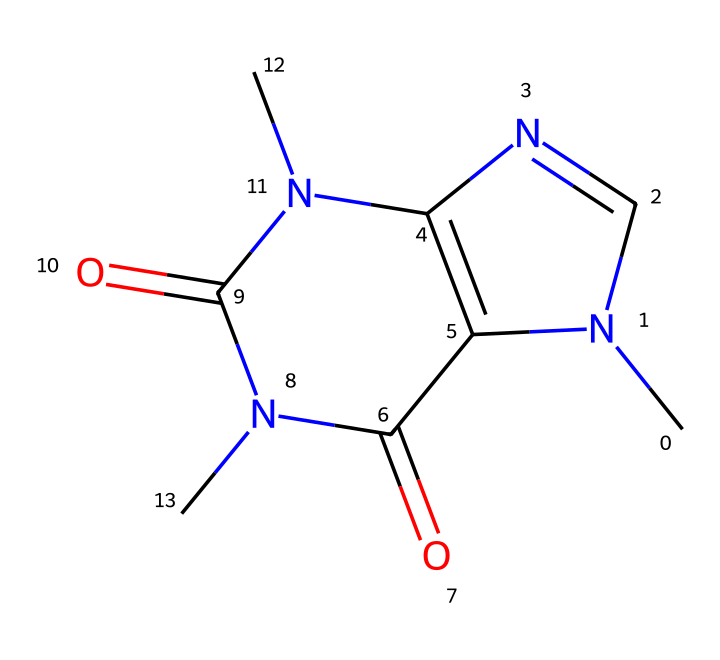What is the molecular formula of caffeine? The SMILES representation contains atoms of carbon (C), nitrogen (N), and oxygen (O). Counting the number of each results in C8, H10, N4, O2, leading to the molecular formula: C8H10N4O2.
Answer: C8H10N4O2 How many nitrogen atoms are present in the caffeine structure? In the SMILES code, there are four nitrogen (N) atoms visualized, which are counted directly from the representation.
Answer: four What type of chemical structure does caffeine have? The representation indicates that caffeine contains multiple rings and nitrogen atoms arranged in a specific configuration, classifying it as a purine alkaloid.
Answer: purine alkaloid Does caffeine contain any functional groups? The caffeine structure has carbonyl (C=O) groups which act as functional groups, specifically within the context of amides and imines.
Answer: carbonyl What is the significance of the nitrogen atoms in caffeine? Nitrogen atoms in caffeine contribute to its properties as an alkaloid, which influences its ability to interact with the central nervous system, thus affecting its stimulant properties.
Answer: stimulant properties Is caffeine classified as a nitrile compound? Although caffeine contains nitrogen, it does not have the cyanide functional group typical to nitrile compounds; hence while it contains nitrogen, it is not classified as a nitrile.
Answer: no 